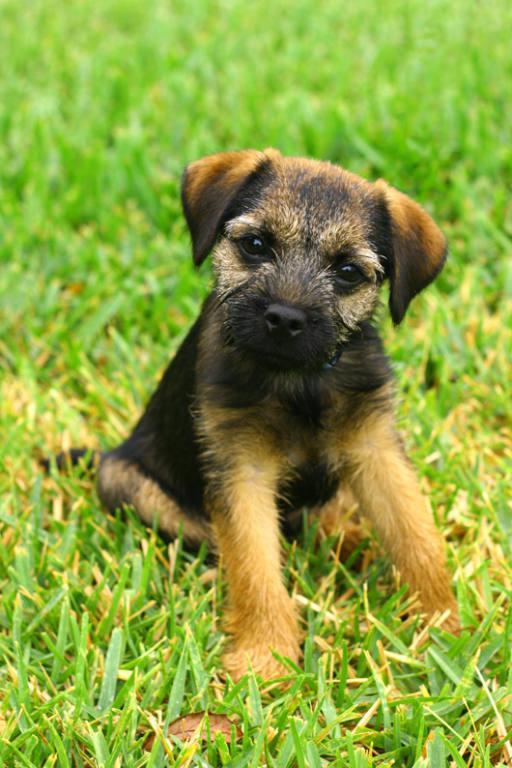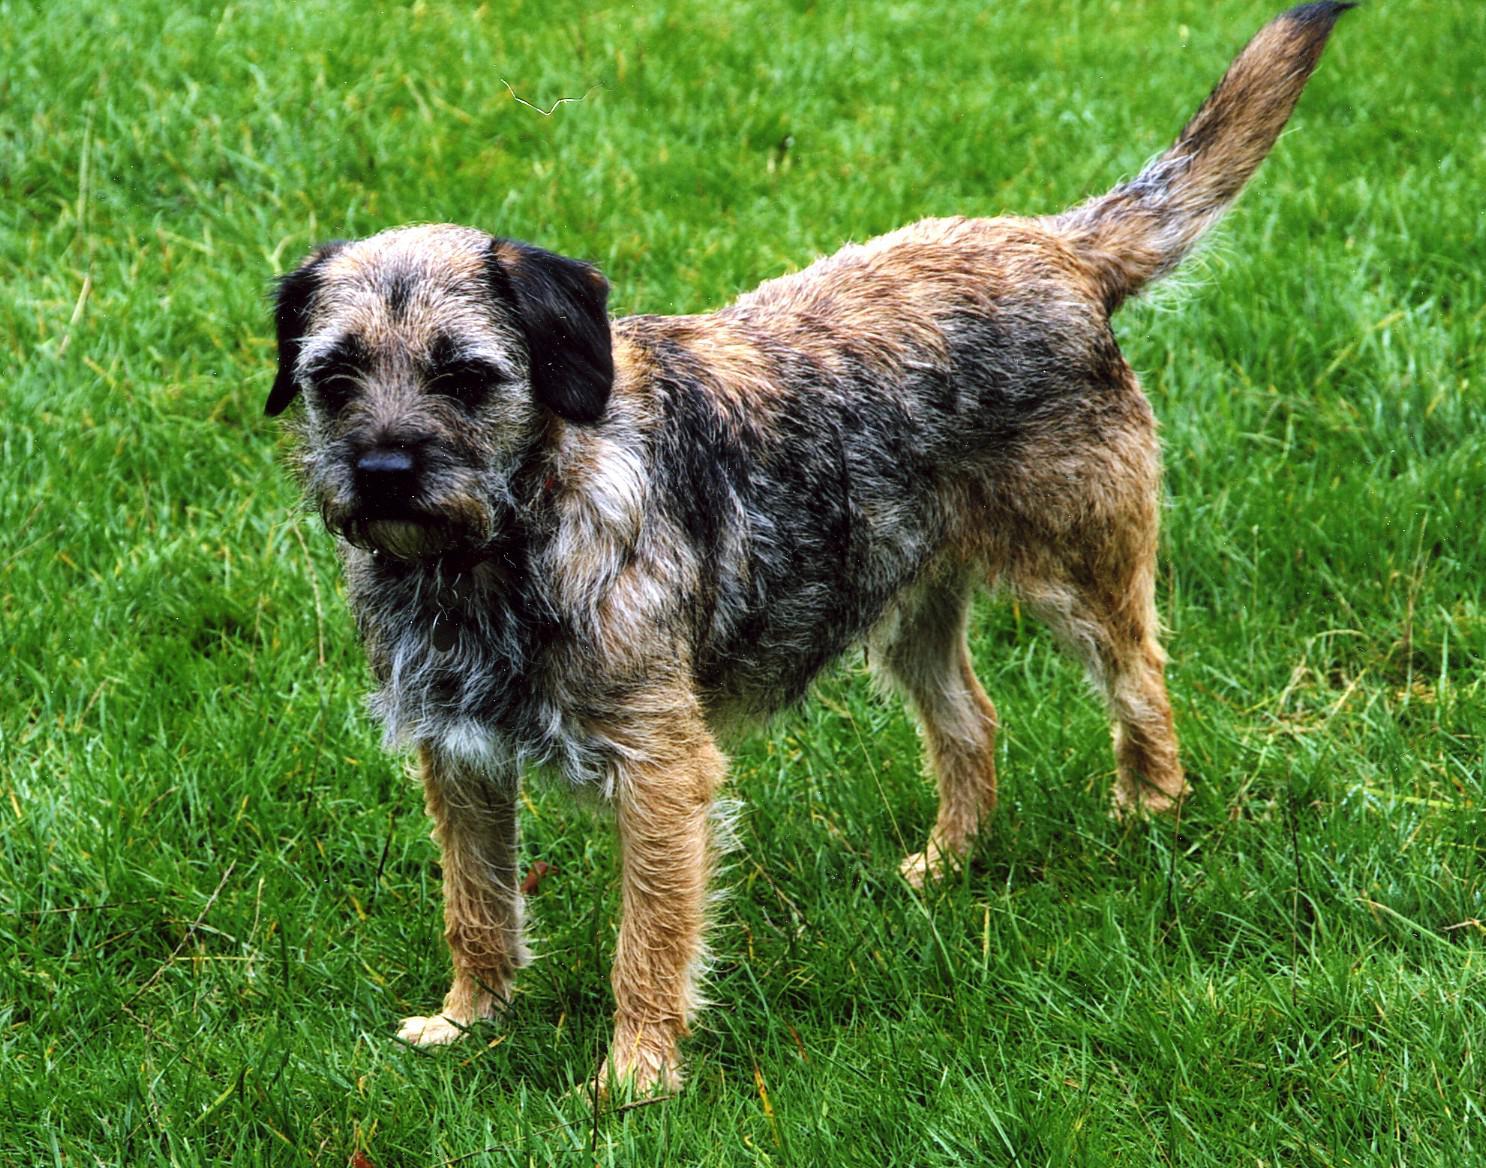The first image is the image on the left, the second image is the image on the right. Evaluate the accuracy of this statement regarding the images: "The right image contains exactly one dog standing on grass facing towards the right.". Is it true? Answer yes or no. No. The first image is the image on the left, the second image is the image on the right. Given the left and right images, does the statement "The dog on each image is facing the opposite direction of where the other is facing." hold true? Answer yes or no. No. The first image is the image on the left, the second image is the image on the right. Considering the images on both sides, is "The dog on the right is standing on grass, but the dog on the left is not standing." valid? Answer yes or no. Yes. 